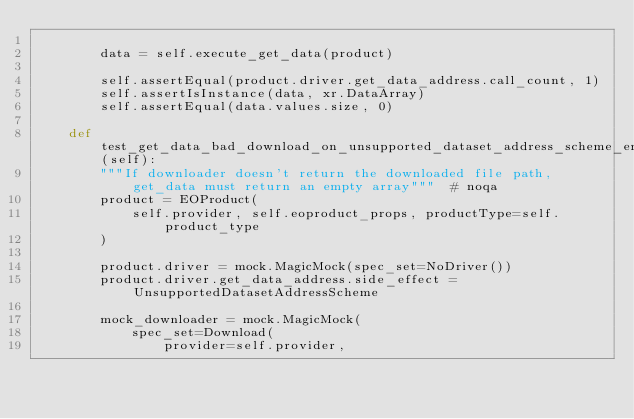Convert code to text. <code><loc_0><loc_0><loc_500><loc_500><_Python_>
        data = self.execute_get_data(product)

        self.assertEqual(product.driver.get_data_address.call_count, 1)
        self.assertIsInstance(data, xr.DataArray)
        self.assertEqual(data.values.size, 0)

    def test_get_data_bad_download_on_unsupported_dataset_address_scheme_error(self):
        """If downloader doesn't return the downloaded file path, get_data must return an empty array"""  # noqa
        product = EOProduct(
            self.provider, self.eoproduct_props, productType=self.product_type
        )

        product.driver = mock.MagicMock(spec_set=NoDriver())
        product.driver.get_data_address.side_effect = UnsupportedDatasetAddressScheme

        mock_downloader = mock.MagicMock(
            spec_set=Download(
                provider=self.provider,</code> 